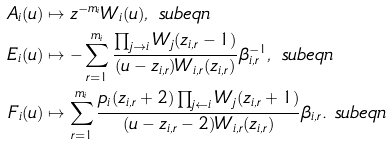Convert formula to latex. <formula><loc_0><loc_0><loc_500><loc_500>A _ { i } ( u ) & \mapsto z ^ { - m _ { i } } W _ { i } ( u ) , \ s u b e q n \\ E _ { i } ( u ) & \mapsto - \sum _ { r = 1 } ^ { m _ { i } } \frac { \prod _ { j \rightarrow i } W _ { j } ( z _ { i , r } - 1 ) } { ( u - z _ { i , r } ) W _ { i , r } ( z _ { i , r } ) } \beta _ { i , r } ^ { - 1 } , \ s u b e q n \\ F _ { i } ( u ) & \mapsto \sum _ { r = 1 } ^ { m _ { i } } \frac { p _ { i } ( z _ { i , r } + 2 ) \prod _ { j \leftarrow i } W _ { j } ( z _ { i , r } + 1 ) } { ( u - z _ { i , r } - 2 ) W _ { i , r } ( z _ { i , r } ) } \beta _ { i , r } . \ s u b e q n</formula> 